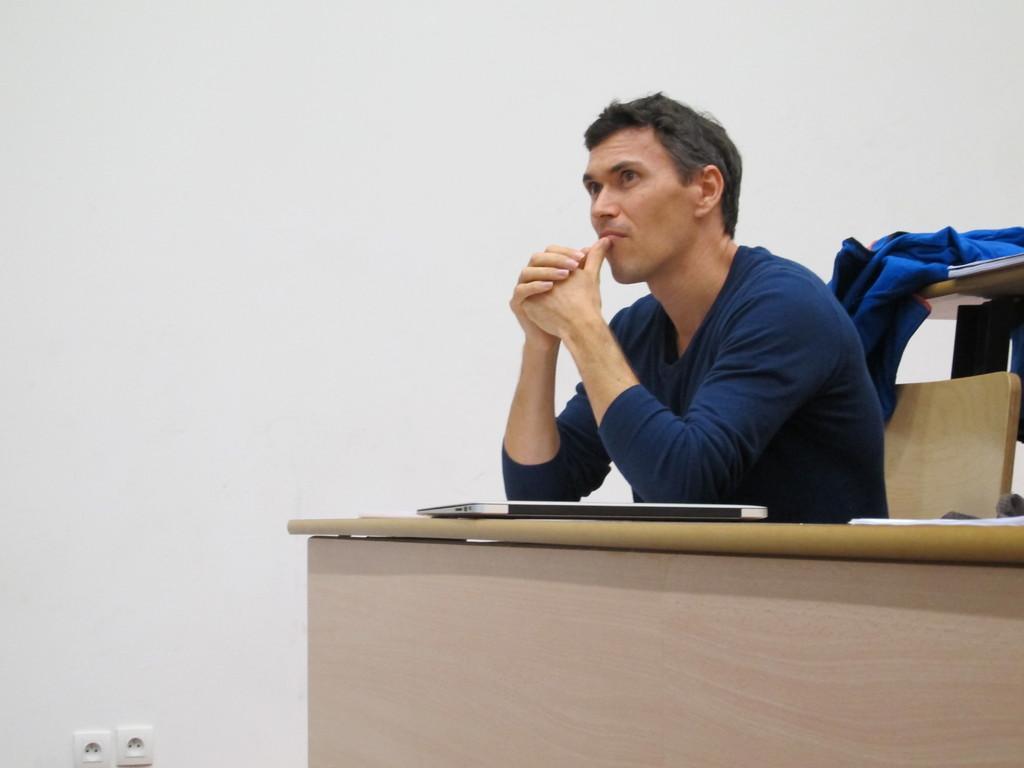Please provide a concise description of this image. In this picture we can see a man who is sitting on the chair. This is table. On the table there is a laptop. And this is wall. 